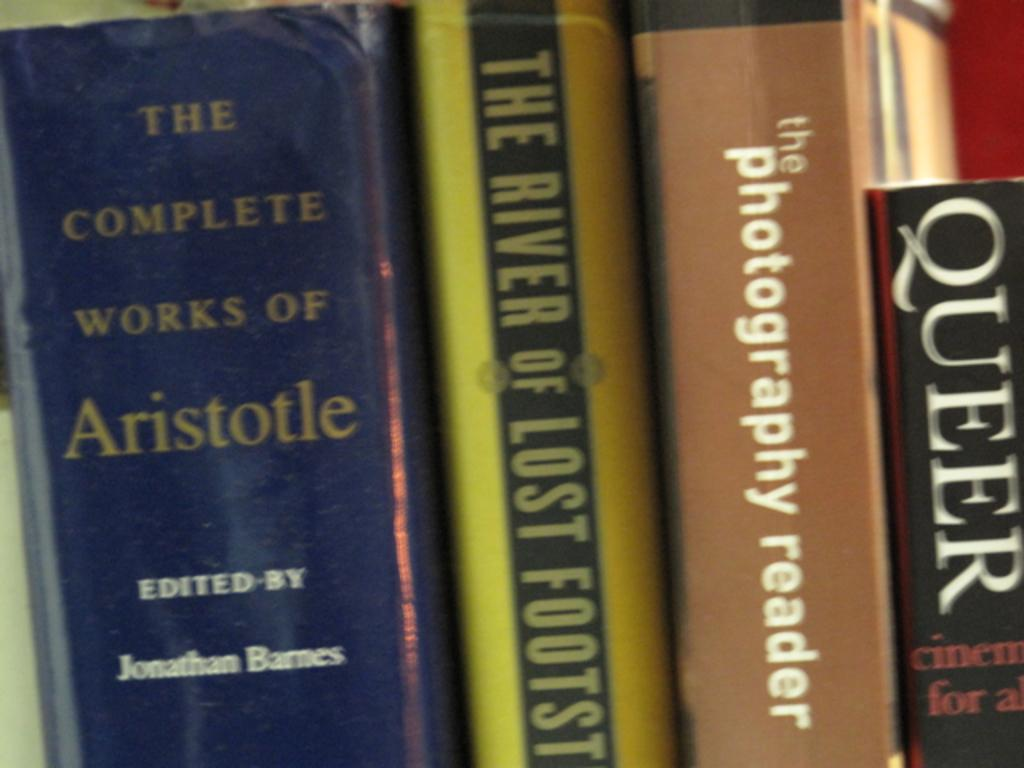<image>
Share a concise interpretation of the image provided. Several books stacked side by side, including The Complete Works of Aristotle and The Photography Reader. 